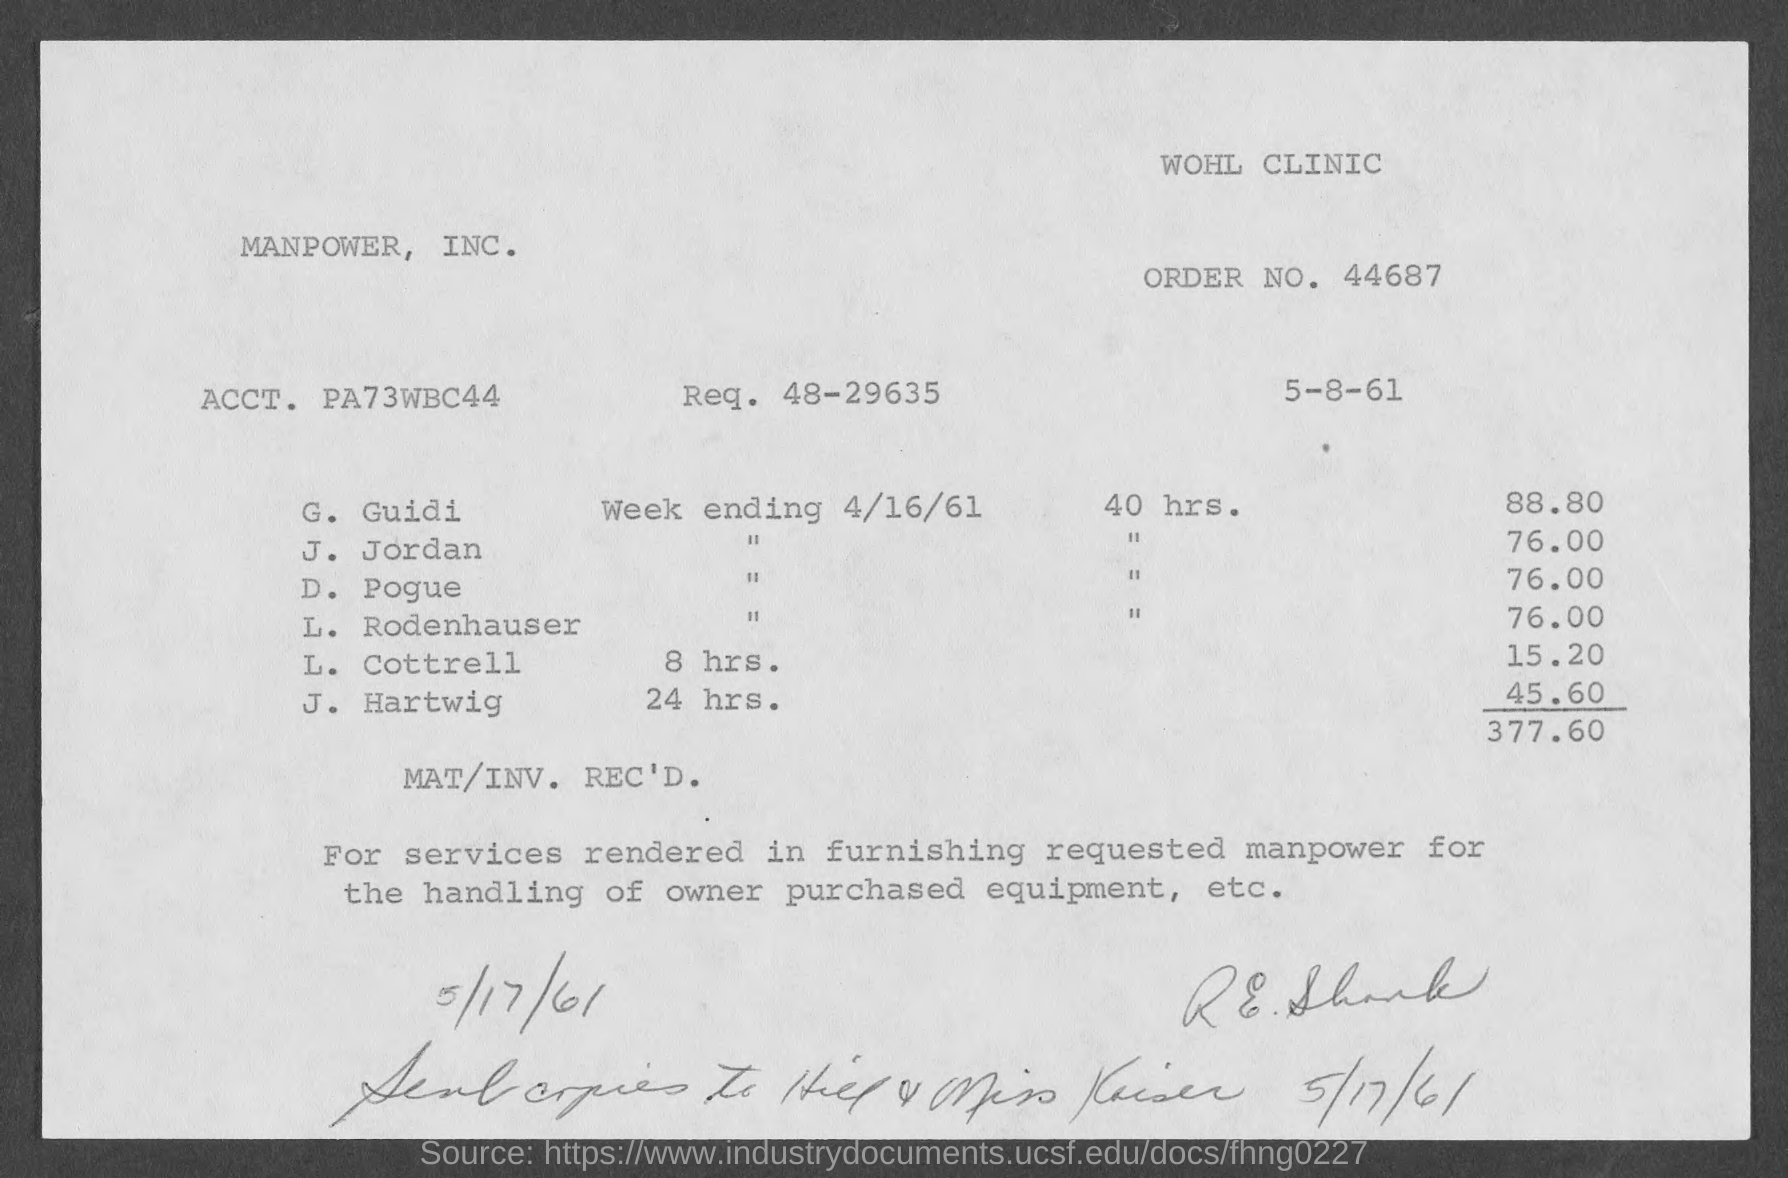Outline some significant characteristics in this image. The order number provided on the invoice is 44687. Please provide the requested number indicated on the invoice, which is 48-29635... The total invoice amount as per the document is $377.60. The issued date of the invoice is May 8, 1961. 